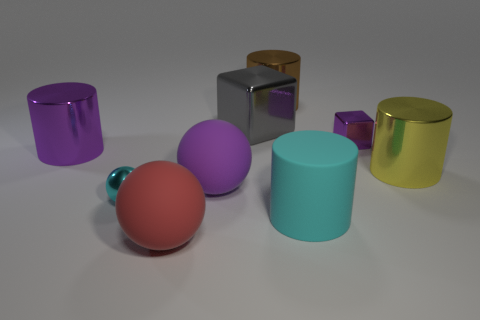Subtract all matte balls. How many balls are left? 1 Add 1 metal cylinders. How many objects exist? 10 Subtract all yellow cylinders. How many cylinders are left? 3 Subtract all cylinders. How many objects are left? 5 Add 6 blue matte cubes. How many blue matte cubes exist? 6 Subtract 0 green spheres. How many objects are left? 9 Subtract 1 blocks. How many blocks are left? 1 Subtract all yellow spheres. Subtract all green cylinders. How many spheres are left? 3 Subtract all tiny purple cubes. Subtract all small purple blocks. How many objects are left? 7 Add 2 cyan metal spheres. How many cyan metal spheres are left? 3 